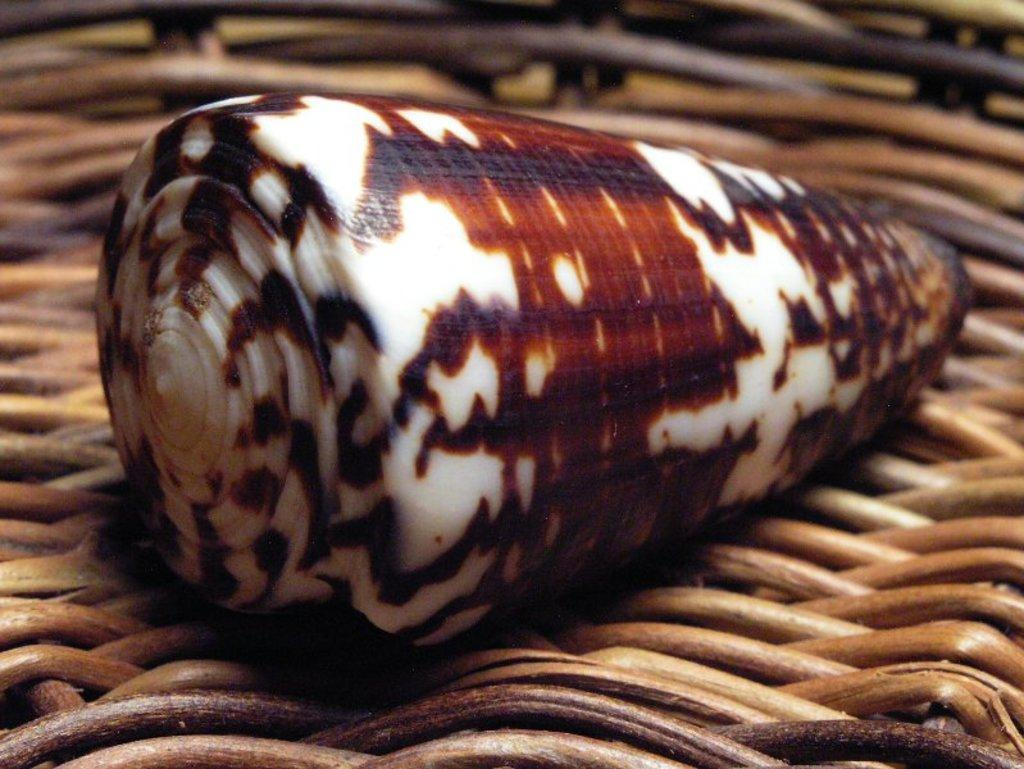What object can be seen in the image? There is a shell in the image. What colors are present on the shell? The shell has brown and white colors. Where is the shell located in the image? The shell is placed on a wooden basket. Can you see the crayon's smile in the image? There is no crayon or smile present in the image; it features a shell on a wooden basket. 